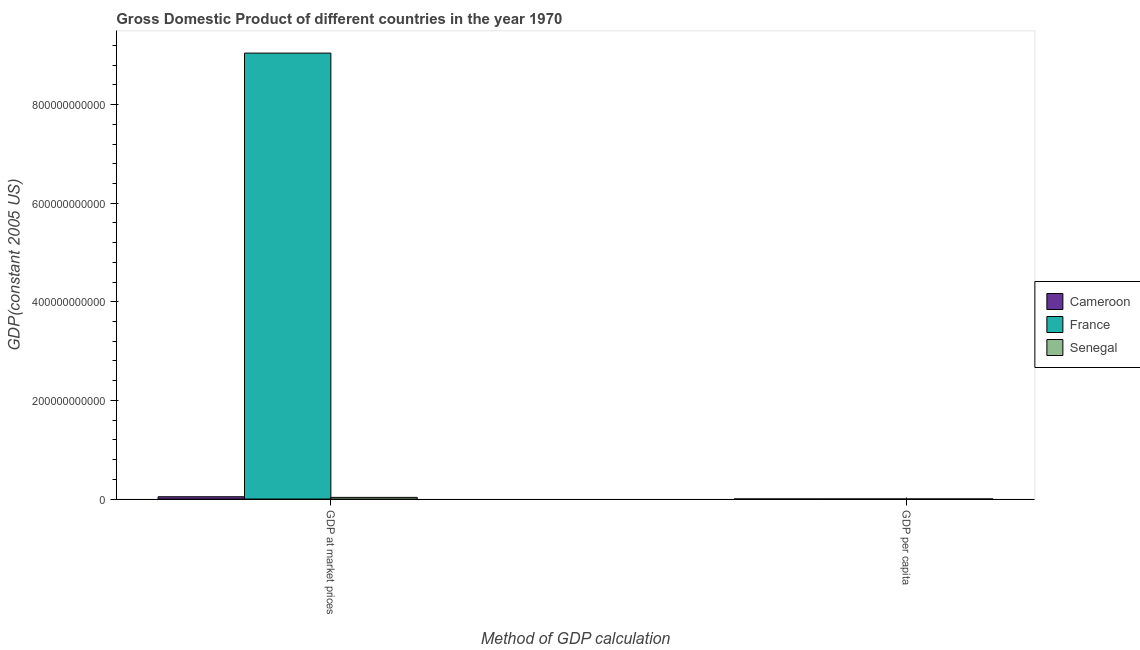How many bars are there on the 1st tick from the left?
Keep it short and to the point. 3. What is the label of the 2nd group of bars from the left?
Make the answer very short. GDP per capita. What is the gdp per capita in France?
Ensure brevity in your answer.  1.74e+04. Across all countries, what is the maximum gdp per capita?
Make the answer very short. 1.74e+04. Across all countries, what is the minimum gdp at market prices?
Ensure brevity in your answer.  3.35e+09. In which country was the gdp per capita maximum?
Your response must be concise. France. In which country was the gdp at market prices minimum?
Your response must be concise. Senegal. What is the total gdp at market prices in the graph?
Provide a succinct answer. 9.12e+11. What is the difference between the gdp at market prices in Senegal and that in France?
Offer a very short reply. -9.01e+11. What is the difference between the gdp at market prices in France and the gdp per capita in Cameroon?
Your response must be concise. 9.04e+11. What is the average gdp per capita per country?
Provide a short and direct response. 6286.28. What is the difference between the gdp at market prices and gdp per capita in Senegal?
Provide a succinct answer. 3.35e+09. What is the ratio of the gdp per capita in Senegal to that in France?
Give a very brief answer. 0.05. In how many countries, is the gdp per capita greater than the average gdp per capita taken over all countries?
Your answer should be very brief. 1. What does the 1st bar from the left in GDP per capita represents?
Your response must be concise. Cameroon. What does the 3rd bar from the right in GDP per capita represents?
Provide a short and direct response. Cameroon. Are all the bars in the graph horizontal?
Offer a very short reply. No. What is the difference between two consecutive major ticks on the Y-axis?
Offer a very short reply. 2.00e+11. Does the graph contain any zero values?
Your answer should be very brief. No. How many legend labels are there?
Provide a short and direct response. 3. What is the title of the graph?
Make the answer very short. Gross Domestic Product of different countries in the year 1970. What is the label or title of the X-axis?
Offer a very short reply. Method of GDP calculation. What is the label or title of the Y-axis?
Offer a terse response. GDP(constant 2005 US). What is the GDP(constant 2005 US) in Cameroon in GDP at market prices?
Your response must be concise. 4.63e+09. What is the GDP(constant 2005 US) of France in GDP at market prices?
Your answer should be compact. 9.04e+11. What is the GDP(constant 2005 US) of Senegal in GDP at market prices?
Your answer should be very brief. 3.35e+09. What is the GDP(constant 2005 US) in Cameroon in GDP per capita?
Provide a short and direct response. 683.51. What is the GDP(constant 2005 US) of France in GDP per capita?
Provide a short and direct response. 1.74e+04. What is the GDP(constant 2005 US) in Senegal in GDP per capita?
Keep it short and to the point. 793.98. Across all Method of GDP calculation, what is the maximum GDP(constant 2005 US) in Cameroon?
Your answer should be compact. 4.63e+09. Across all Method of GDP calculation, what is the maximum GDP(constant 2005 US) of France?
Ensure brevity in your answer.  9.04e+11. Across all Method of GDP calculation, what is the maximum GDP(constant 2005 US) of Senegal?
Ensure brevity in your answer.  3.35e+09. Across all Method of GDP calculation, what is the minimum GDP(constant 2005 US) in Cameroon?
Ensure brevity in your answer.  683.51. Across all Method of GDP calculation, what is the minimum GDP(constant 2005 US) in France?
Ensure brevity in your answer.  1.74e+04. Across all Method of GDP calculation, what is the minimum GDP(constant 2005 US) of Senegal?
Offer a terse response. 793.98. What is the total GDP(constant 2005 US) of Cameroon in the graph?
Provide a succinct answer. 4.63e+09. What is the total GDP(constant 2005 US) in France in the graph?
Provide a short and direct response. 9.04e+11. What is the total GDP(constant 2005 US) of Senegal in the graph?
Offer a very short reply. 3.35e+09. What is the difference between the GDP(constant 2005 US) of Cameroon in GDP at market prices and that in GDP per capita?
Offer a terse response. 4.63e+09. What is the difference between the GDP(constant 2005 US) in France in GDP at market prices and that in GDP per capita?
Offer a very short reply. 9.04e+11. What is the difference between the GDP(constant 2005 US) in Senegal in GDP at market prices and that in GDP per capita?
Ensure brevity in your answer.  3.35e+09. What is the difference between the GDP(constant 2005 US) in Cameroon in GDP at market prices and the GDP(constant 2005 US) in France in GDP per capita?
Your response must be concise. 4.63e+09. What is the difference between the GDP(constant 2005 US) in Cameroon in GDP at market prices and the GDP(constant 2005 US) in Senegal in GDP per capita?
Ensure brevity in your answer.  4.63e+09. What is the difference between the GDP(constant 2005 US) of France in GDP at market prices and the GDP(constant 2005 US) of Senegal in GDP per capita?
Your answer should be compact. 9.04e+11. What is the average GDP(constant 2005 US) in Cameroon per Method of GDP calculation?
Make the answer very short. 2.31e+09. What is the average GDP(constant 2005 US) of France per Method of GDP calculation?
Provide a short and direct response. 4.52e+11. What is the average GDP(constant 2005 US) in Senegal per Method of GDP calculation?
Offer a terse response. 1.67e+09. What is the difference between the GDP(constant 2005 US) of Cameroon and GDP(constant 2005 US) of France in GDP at market prices?
Keep it short and to the point. -9.00e+11. What is the difference between the GDP(constant 2005 US) in Cameroon and GDP(constant 2005 US) in Senegal in GDP at market prices?
Offer a very short reply. 1.28e+09. What is the difference between the GDP(constant 2005 US) in France and GDP(constant 2005 US) in Senegal in GDP at market prices?
Ensure brevity in your answer.  9.01e+11. What is the difference between the GDP(constant 2005 US) of Cameroon and GDP(constant 2005 US) of France in GDP per capita?
Your answer should be very brief. -1.67e+04. What is the difference between the GDP(constant 2005 US) in Cameroon and GDP(constant 2005 US) in Senegal in GDP per capita?
Offer a terse response. -110.48. What is the difference between the GDP(constant 2005 US) in France and GDP(constant 2005 US) in Senegal in GDP per capita?
Make the answer very short. 1.66e+04. What is the ratio of the GDP(constant 2005 US) of Cameroon in GDP at market prices to that in GDP per capita?
Offer a very short reply. 6.77e+06. What is the ratio of the GDP(constant 2005 US) of France in GDP at market prices to that in GDP per capita?
Provide a short and direct response. 5.20e+07. What is the ratio of the GDP(constant 2005 US) of Senegal in GDP at market prices to that in GDP per capita?
Offer a very short reply. 4.22e+06. What is the difference between the highest and the second highest GDP(constant 2005 US) in Cameroon?
Offer a very short reply. 4.63e+09. What is the difference between the highest and the second highest GDP(constant 2005 US) in France?
Offer a terse response. 9.04e+11. What is the difference between the highest and the second highest GDP(constant 2005 US) in Senegal?
Provide a short and direct response. 3.35e+09. What is the difference between the highest and the lowest GDP(constant 2005 US) in Cameroon?
Your answer should be compact. 4.63e+09. What is the difference between the highest and the lowest GDP(constant 2005 US) of France?
Ensure brevity in your answer.  9.04e+11. What is the difference between the highest and the lowest GDP(constant 2005 US) in Senegal?
Make the answer very short. 3.35e+09. 